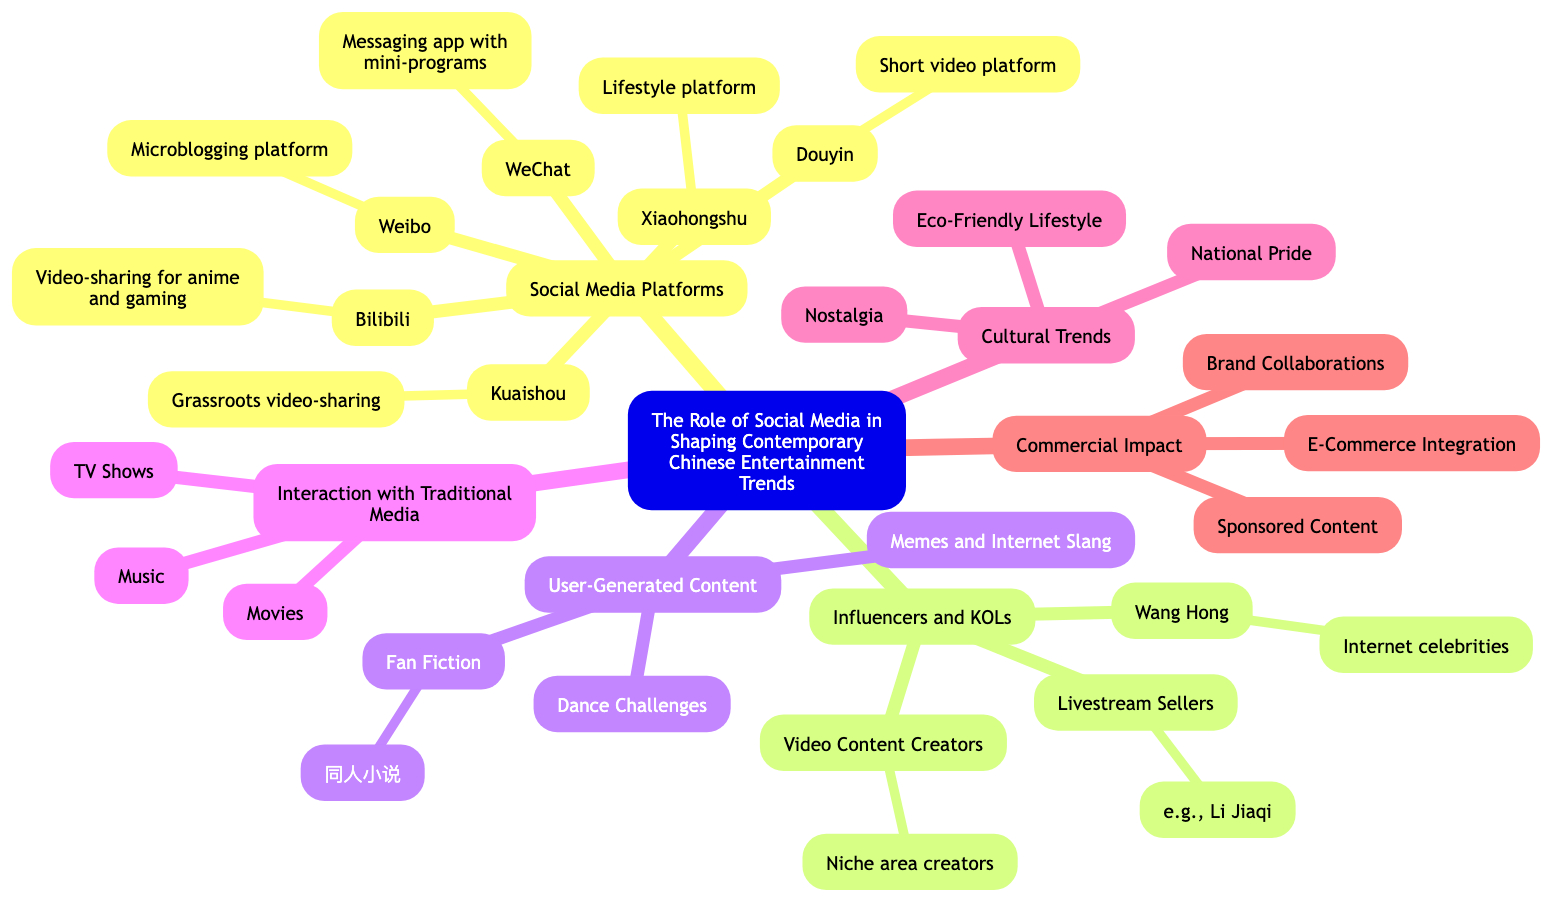What are the main social media platforms mentioned? The main social media platforms branch under the "Social Media Platforms" node, which lists Weibo, WeChat, Douyin, Bilibili, Xiaohongshu, and Kuaishou.
Answer: Weibo, WeChat, Douyin, Bilibili, Xiaohongshu, Kuaishou How many types of content creators are listed under Influencers and KOLs? Under the "Influencers and KOLs" node, there are three types of content creators: Wang Hong, Livestream Sellers, and Video Content Creators. This is a direct counting of the branches under that node.
Answer: 3 Which social media platform is known for its microblogging? The "Weibo" node describes it as a microblogging platform. Since the question asks for the specific platform, it directly refers to Weibo.
Answer: Weibo What type of user-generated content is associated with viral dance trends? The "Dance Challenges" node under "User-Generated Content" describes content that originates from platforms like Douyin and Kuaishou. This ties dance challenges directly to user-generated content.
Answer: Dance Challenges How does social media interact with traditional media according to the diagram? The "Interaction with Traditional Media" section highlights how TV shows, movies, and music integrate social media for audience engagement or promotions. The interaction emphasizes the cross-functionality of these media types with social platforms.
Answer: TV Shows, Movies, Music What cultural trend relates to traditional elements in modern content? The "Nostalgia" node under "Cultural Trends" specifically refers to the revival of traditional elements, which indicates how modern content reflects past cultural aspects.
Answer: Nostalgia How many subcategories fall under the Commercial Impact section? The "Commercial Impact" section comprises three subcategories: Brand Collaborations, E-Commerce Integration, and Sponsored Content. Counting these branches yields the number of subcategories.
Answer: 3 What kind of content do Livestream Sellers focus on? Under the "Livestream Sellers" node, it indicates these influencers introduce and sell products live, representing their primary focus within the broader influencer category.
Answer: Products 